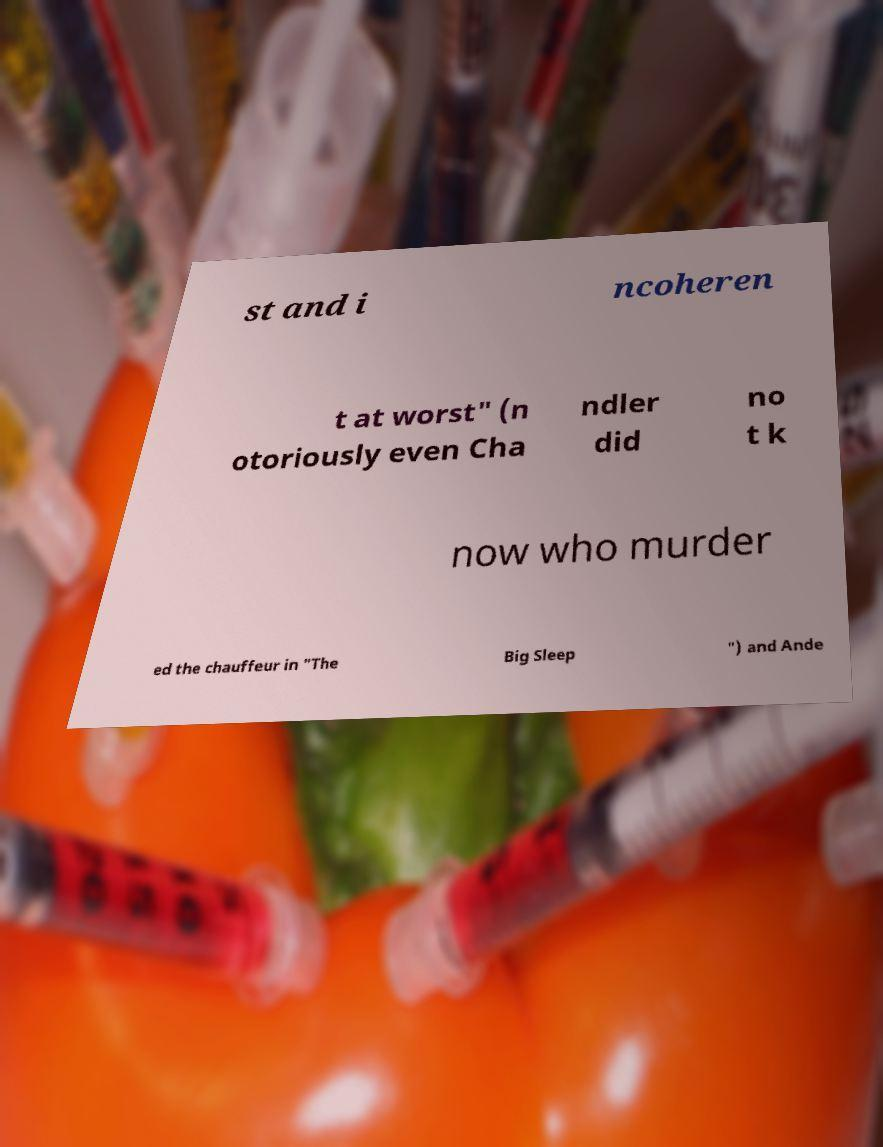Can you accurately transcribe the text from the provided image for me? st and i ncoheren t at worst" (n otoriously even Cha ndler did no t k now who murder ed the chauffeur in "The Big Sleep ") and Ande 